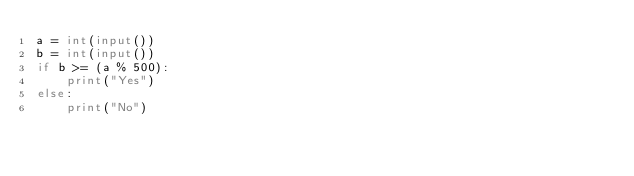Convert code to text. <code><loc_0><loc_0><loc_500><loc_500><_Python_>a = int(input())
b = int(input())
if b >= (a % 500):
    print("Yes")
else:
    print("No")
</code> 